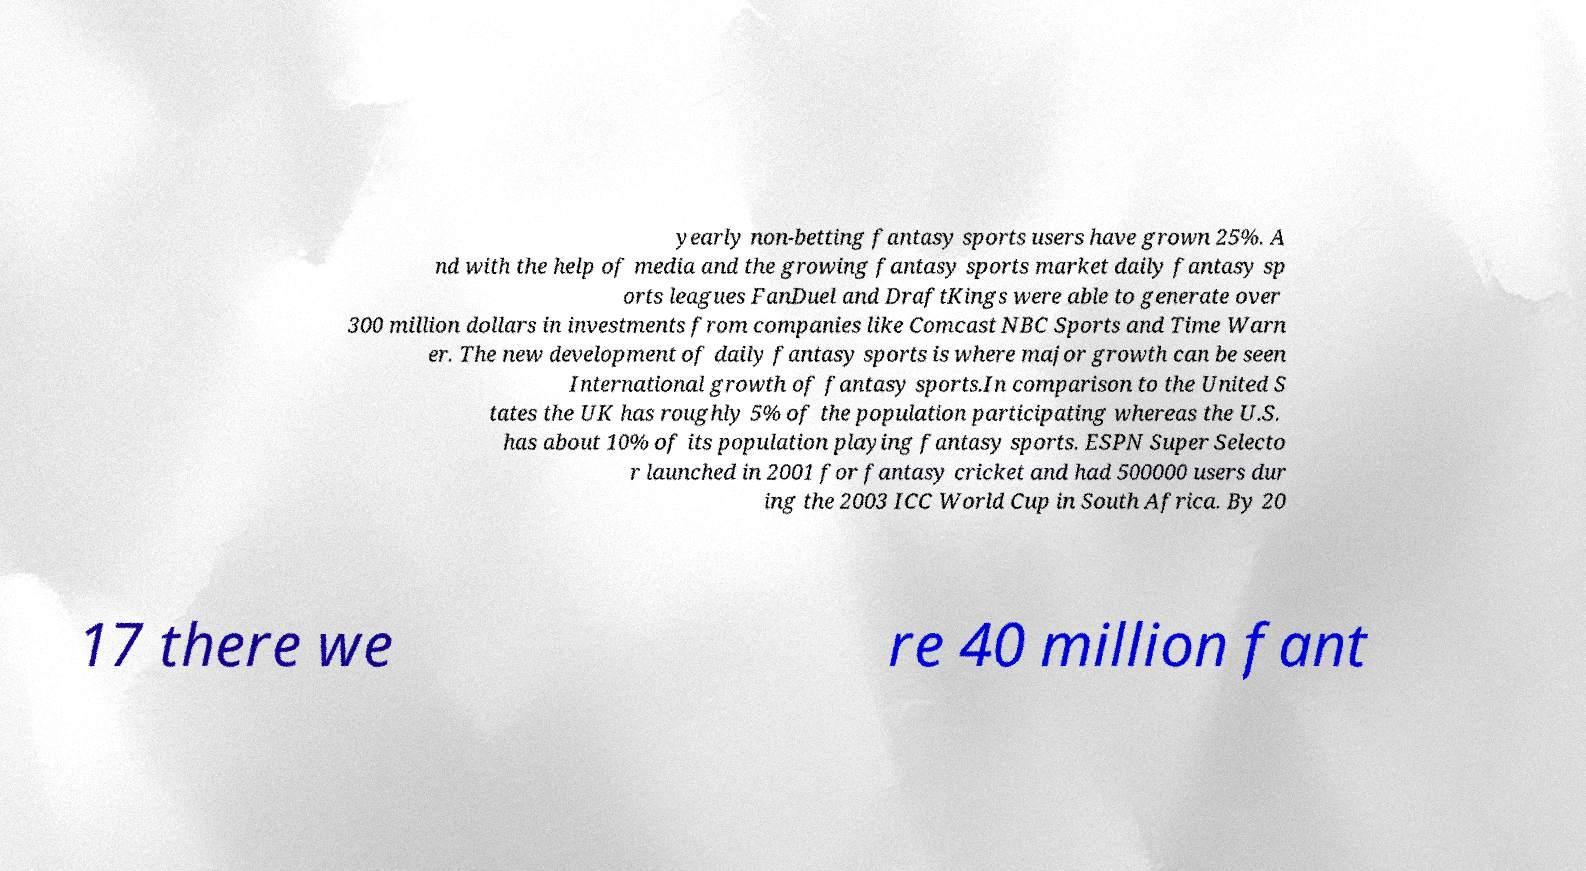Could you extract and type out the text from this image? yearly non-betting fantasy sports users have grown 25%. A nd with the help of media and the growing fantasy sports market daily fantasy sp orts leagues FanDuel and DraftKings were able to generate over 300 million dollars in investments from companies like Comcast NBC Sports and Time Warn er. The new development of daily fantasy sports is where major growth can be seen International growth of fantasy sports.In comparison to the United S tates the UK has roughly 5% of the population participating whereas the U.S. has about 10% of its population playing fantasy sports. ESPN Super Selecto r launched in 2001 for fantasy cricket and had 500000 users dur ing the 2003 ICC World Cup in South Africa. By 20 17 there we re 40 million fant 